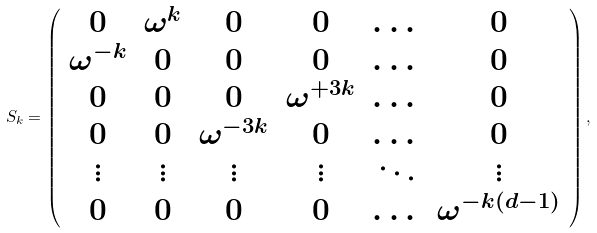<formula> <loc_0><loc_0><loc_500><loc_500>S _ { k } = \left ( \begin{array} { c c c c c c } 0 & \omega ^ { k } & 0 & 0 & \dots & 0 \\ \omega ^ { - k } & 0 & 0 & 0 & \dots & 0 \\ 0 & 0 & 0 & \omega ^ { + 3 k } & \dots & 0 \\ 0 & 0 & \omega ^ { - 3 k } & 0 & \dots & 0 \\ \vdots & \vdots & \vdots & \vdots & \ddots & \vdots \\ 0 & 0 & 0 & 0 & \dots & \omega ^ { - k ( d - 1 ) } \\ \end{array} \right ) ,</formula> 